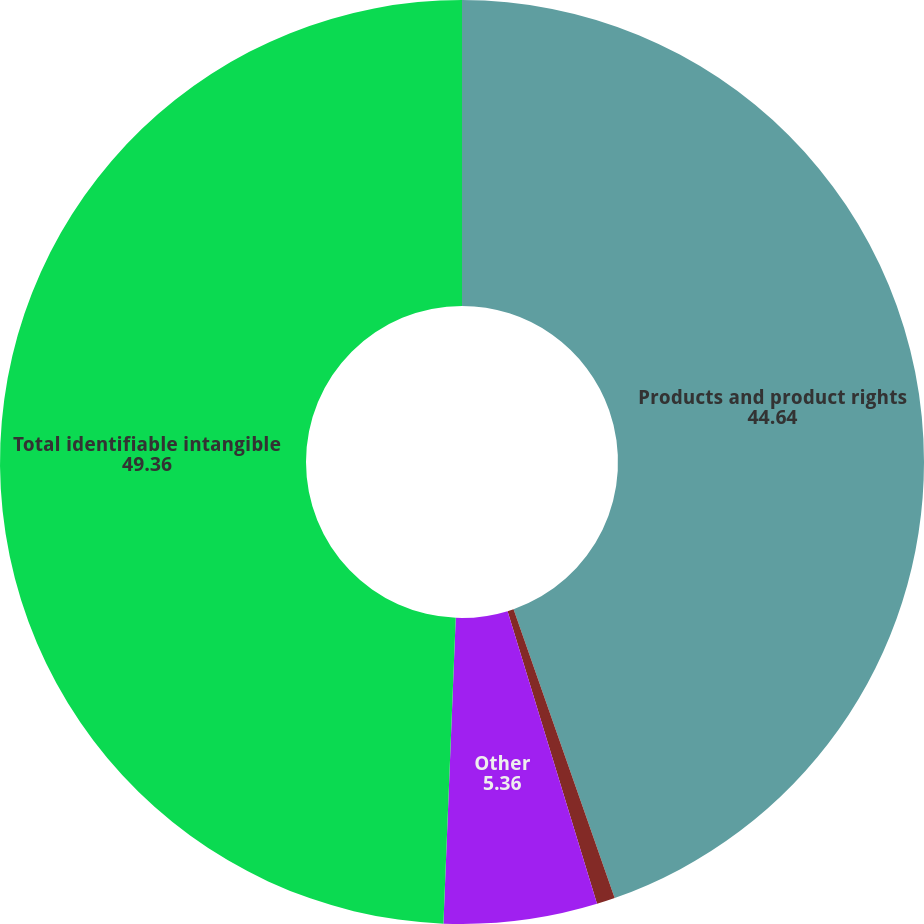Convert chart to OTSL. <chart><loc_0><loc_0><loc_500><loc_500><pie_chart><fcel>Products and product rights<fcel>Tradenames<fcel>Other<fcel>Total identifiable intangible<nl><fcel>44.64%<fcel>0.64%<fcel>5.36%<fcel>49.36%<nl></chart> 